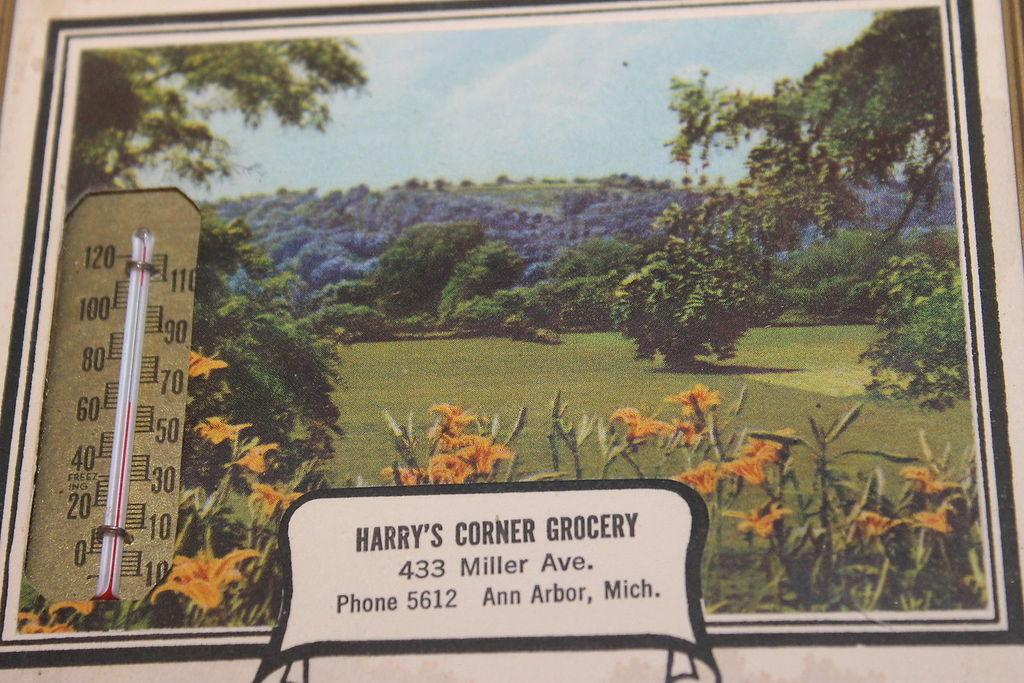<image>
Create a compact narrative representing the image presented. Harry's Corner Grocery is located at 433 Miller Ave., according to this sign. 